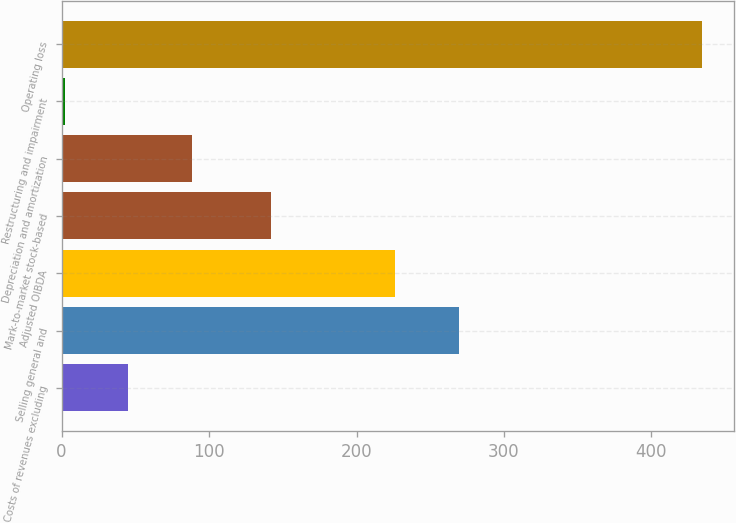Convert chart to OTSL. <chart><loc_0><loc_0><loc_500><loc_500><bar_chart><fcel>Costs of revenues excluding<fcel>Selling general and<fcel>Adjusted OIBDA<fcel>Mark-to-market stock-based<fcel>Depreciation and amortization<fcel>Restructuring and impairment<fcel>Operating loss<nl><fcel>45.2<fcel>269.2<fcel>226<fcel>142<fcel>88.4<fcel>2<fcel>434<nl></chart> 